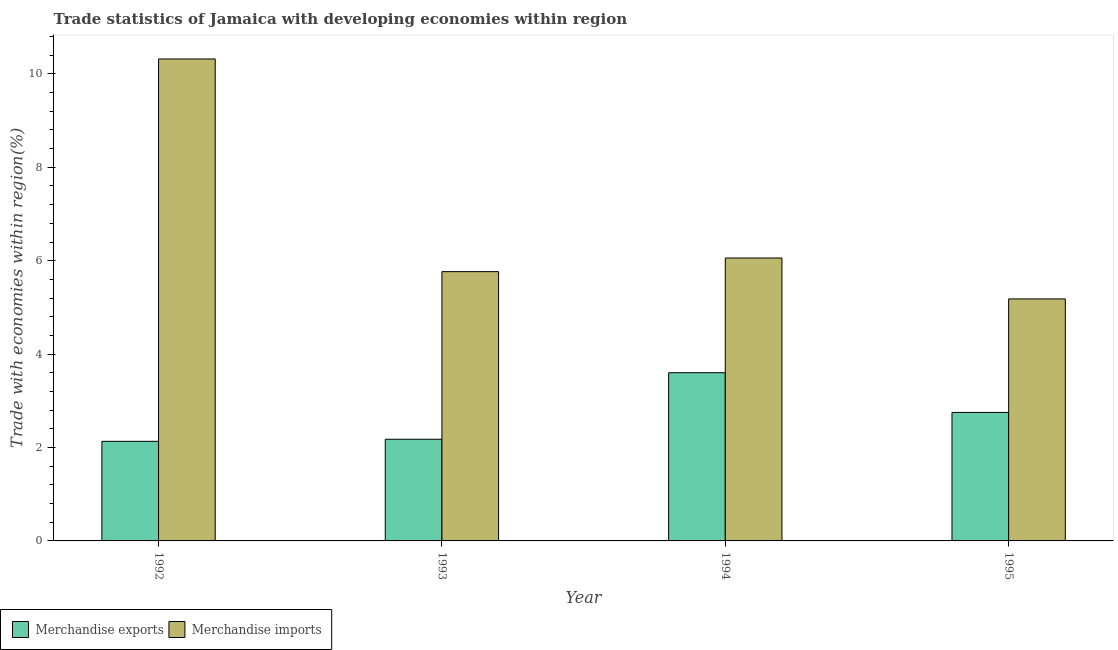How many groups of bars are there?
Offer a very short reply. 4. How many bars are there on the 2nd tick from the left?
Offer a terse response. 2. How many bars are there on the 4th tick from the right?
Provide a short and direct response. 2. What is the label of the 2nd group of bars from the left?
Ensure brevity in your answer.  1993. What is the merchandise imports in 1994?
Ensure brevity in your answer.  6.06. Across all years, what is the maximum merchandise imports?
Ensure brevity in your answer.  10.32. Across all years, what is the minimum merchandise imports?
Give a very brief answer. 5.18. In which year was the merchandise imports minimum?
Offer a very short reply. 1995. What is the total merchandise imports in the graph?
Give a very brief answer. 27.33. What is the difference between the merchandise imports in 1993 and that in 1995?
Give a very brief answer. 0.58. What is the difference between the merchandise exports in 1992 and the merchandise imports in 1993?
Your response must be concise. -0.04. What is the average merchandise exports per year?
Provide a succinct answer. 2.67. What is the ratio of the merchandise imports in 1993 to that in 1994?
Ensure brevity in your answer.  0.95. Is the merchandise exports in 1992 less than that in 1995?
Your answer should be compact. Yes. What is the difference between the highest and the second highest merchandise imports?
Give a very brief answer. 4.26. What is the difference between the highest and the lowest merchandise exports?
Offer a very short reply. 1.47. Is the sum of the merchandise imports in 1993 and 1994 greater than the maximum merchandise exports across all years?
Your answer should be compact. Yes. What does the 1st bar from the right in 1995 represents?
Keep it short and to the point. Merchandise imports. Are all the bars in the graph horizontal?
Ensure brevity in your answer.  No. How many years are there in the graph?
Your response must be concise. 4. What is the difference between two consecutive major ticks on the Y-axis?
Make the answer very short. 2. Where does the legend appear in the graph?
Offer a terse response. Bottom left. How are the legend labels stacked?
Offer a terse response. Horizontal. What is the title of the graph?
Your response must be concise. Trade statistics of Jamaica with developing economies within region. Does "Export" appear as one of the legend labels in the graph?
Provide a succinct answer. No. What is the label or title of the Y-axis?
Ensure brevity in your answer.  Trade with economies within region(%). What is the Trade with economies within region(%) of Merchandise exports in 1992?
Make the answer very short. 2.13. What is the Trade with economies within region(%) of Merchandise imports in 1992?
Provide a short and direct response. 10.32. What is the Trade with economies within region(%) in Merchandise exports in 1993?
Provide a short and direct response. 2.18. What is the Trade with economies within region(%) in Merchandise imports in 1993?
Provide a succinct answer. 5.77. What is the Trade with economies within region(%) of Merchandise exports in 1994?
Offer a terse response. 3.6. What is the Trade with economies within region(%) in Merchandise imports in 1994?
Provide a short and direct response. 6.06. What is the Trade with economies within region(%) of Merchandise exports in 1995?
Keep it short and to the point. 2.75. What is the Trade with economies within region(%) of Merchandise imports in 1995?
Ensure brevity in your answer.  5.18. Across all years, what is the maximum Trade with economies within region(%) in Merchandise exports?
Ensure brevity in your answer.  3.6. Across all years, what is the maximum Trade with economies within region(%) in Merchandise imports?
Offer a very short reply. 10.32. Across all years, what is the minimum Trade with economies within region(%) in Merchandise exports?
Offer a very short reply. 2.13. Across all years, what is the minimum Trade with economies within region(%) in Merchandise imports?
Provide a short and direct response. 5.18. What is the total Trade with economies within region(%) of Merchandise exports in the graph?
Ensure brevity in your answer.  10.66. What is the total Trade with economies within region(%) of Merchandise imports in the graph?
Ensure brevity in your answer.  27.32. What is the difference between the Trade with economies within region(%) in Merchandise exports in 1992 and that in 1993?
Your answer should be compact. -0.04. What is the difference between the Trade with economies within region(%) of Merchandise imports in 1992 and that in 1993?
Offer a very short reply. 4.55. What is the difference between the Trade with economies within region(%) in Merchandise exports in 1992 and that in 1994?
Provide a succinct answer. -1.47. What is the difference between the Trade with economies within region(%) in Merchandise imports in 1992 and that in 1994?
Your response must be concise. 4.26. What is the difference between the Trade with economies within region(%) in Merchandise exports in 1992 and that in 1995?
Make the answer very short. -0.62. What is the difference between the Trade with economies within region(%) in Merchandise imports in 1992 and that in 1995?
Offer a terse response. 5.14. What is the difference between the Trade with economies within region(%) of Merchandise exports in 1993 and that in 1994?
Ensure brevity in your answer.  -1.42. What is the difference between the Trade with economies within region(%) of Merchandise imports in 1993 and that in 1994?
Offer a very short reply. -0.29. What is the difference between the Trade with economies within region(%) in Merchandise exports in 1993 and that in 1995?
Your response must be concise. -0.57. What is the difference between the Trade with economies within region(%) of Merchandise imports in 1993 and that in 1995?
Give a very brief answer. 0.58. What is the difference between the Trade with economies within region(%) of Merchandise exports in 1994 and that in 1995?
Offer a very short reply. 0.85. What is the difference between the Trade with economies within region(%) of Merchandise imports in 1994 and that in 1995?
Ensure brevity in your answer.  0.88. What is the difference between the Trade with economies within region(%) of Merchandise exports in 1992 and the Trade with economies within region(%) of Merchandise imports in 1993?
Offer a very short reply. -3.63. What is the difference between the Trade with economies within region(%) of Merchandise exports in 1992 and the Trade with economies within region(%) of Merchandise imports in 1994?
Your response must be concise. -3.93. What is the difference between the Trade with economies within region(%) in Merchandise exports in 1992 and the Trade with economies within region(%) in Merchandise imports in 1995?
Give a very brief answer. -3.05. What is the difference between the Trade with economies within region(%) of Merchandise exports in 1993 and the Trade with economies within region(%) of Merchandise imports in 1994?
Your response must be concise. -3.88. What is the difference between the Trade with economies within region(%) of Merchandise exports in 1993 and the Trade with economies within region(%) of Merchandise imports in 1995?
Your answer should be compact. -3. What is the difference between the Trade with economies within region(%) of Merchandise exports in 1994 and the Trade with economies within region(%) of Merchandise imports in 1995?
Offer a very short reply. -1.58. What is the average Trade with economies within region(%) in Merchandise exports per year?
Provide a short and direct response. 2.67. What is the average Trade with economies within region(%) of Merchandise imports per year?
Your answer should be compact. 6.83. In the year 1992, what is the difference between the Trade with economies within region(%) in Merchandise exports and Trade with economies within region(%) in Merchandise imports?
Keep it short and to the point. -8.19. In the year 1993, what is the difference between the Trade with economies within region(%) in Merchandise exports and Trade with economies within region(%) in Merchandise imports?
Your answer should be compact. -3.59. In the year 1994, what is the difference between the Trade with economies within region(%) of Merchandise exports and Trade with economies within region(%) of Merchandise imports?
Offer a terse response. -2.46. In the year 1995, what is the difference between the Trade with economies within region(%) in Merchandise exports and Trade with economies within region(%) in Merchandise imports?
Give a very brief answer. -2.43. What is the ratio of the Trade with economies within region(%) in Merchandise exports in 1992 to that in 1993?
Your answer should be very brief. 0.98. What is the ratio of the Trade with economies within region(%) in Merchandise imports in 1992 to that in 1993?
Ensure brevity in your answer.  1.79. What is the ratio of the Trade with economies within region(%) of Merchandise exports in 1992 to that in 1994?
Provide a short and direct response. 0.59. What is the ratio of the Trade with economies within region(%) of Merchandise imports in 1992 to that in 1994?
Give a very brief answer. 1.7. What is the ratio of the Trade with economies within region(%) of Merchandise exports in 1992 to that in 1995?
Offer a terse response. 0.78. What is the ratio of the Trade with economies within region(%) of Merchandise imports in 1992 to that in 1995?
Offer a terse response. 1.99. What is the ratio of the Trade with economies within region(%) in Merchandise exports in 1993 to that in 1994?
Ensure brevity in your answer.  0.6. What is the ratio of the Trade with economies within region(%) of Merchandise imports in 1993 to that in 1994?
Your answer should be very brief. 0.95. What is the ratio of the Trade with economies within region(%) of Merchandise exports in 1993 to that in 1995?
Provide a short and direct response. 0.79. What is the ratio of the Trade with economies within region(%) in Merchandise imports in 1993 to that in 1995?
Your answer should be very brief. 1.11. What is the ratio of the Trade with economies within region(%) in Merchandise exports in 1994 to that in 1995?
Your answer should be very brief. 1.31. What is the ratio of the Trade with economies within region(%) in Merchandise imports in 1994 to that in 1995?
Your answer should be compact. 1.17. What is the difference between the highest and the second highest Trade with economies within region(%) of Merchandise exports?
Ensure brevity in your answer.  0.85. What is the difference between the highest and the second highest Trade with economies within region(%) of Merchandise imports?
Your answer should be very brief. 4.26. What is the difference between the highest and the lowest Trade with economies within region(%) in Merchandise exports?
Provide a succinct answer. 1.47. What is the difference between the highest and the lowest Trade with economies within region(%) in Merchandise imports?
Your answer should be compact. 5.14. 